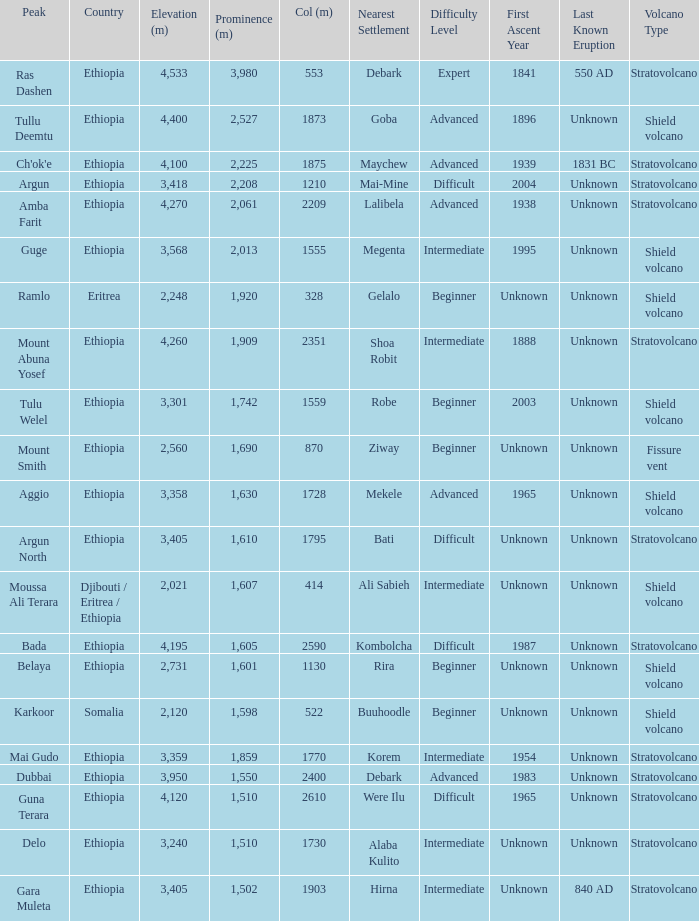What is the total prominence number in m of ethiopia, which has a col in m of 1728 and an elevation less than 3,358? 0.0. 